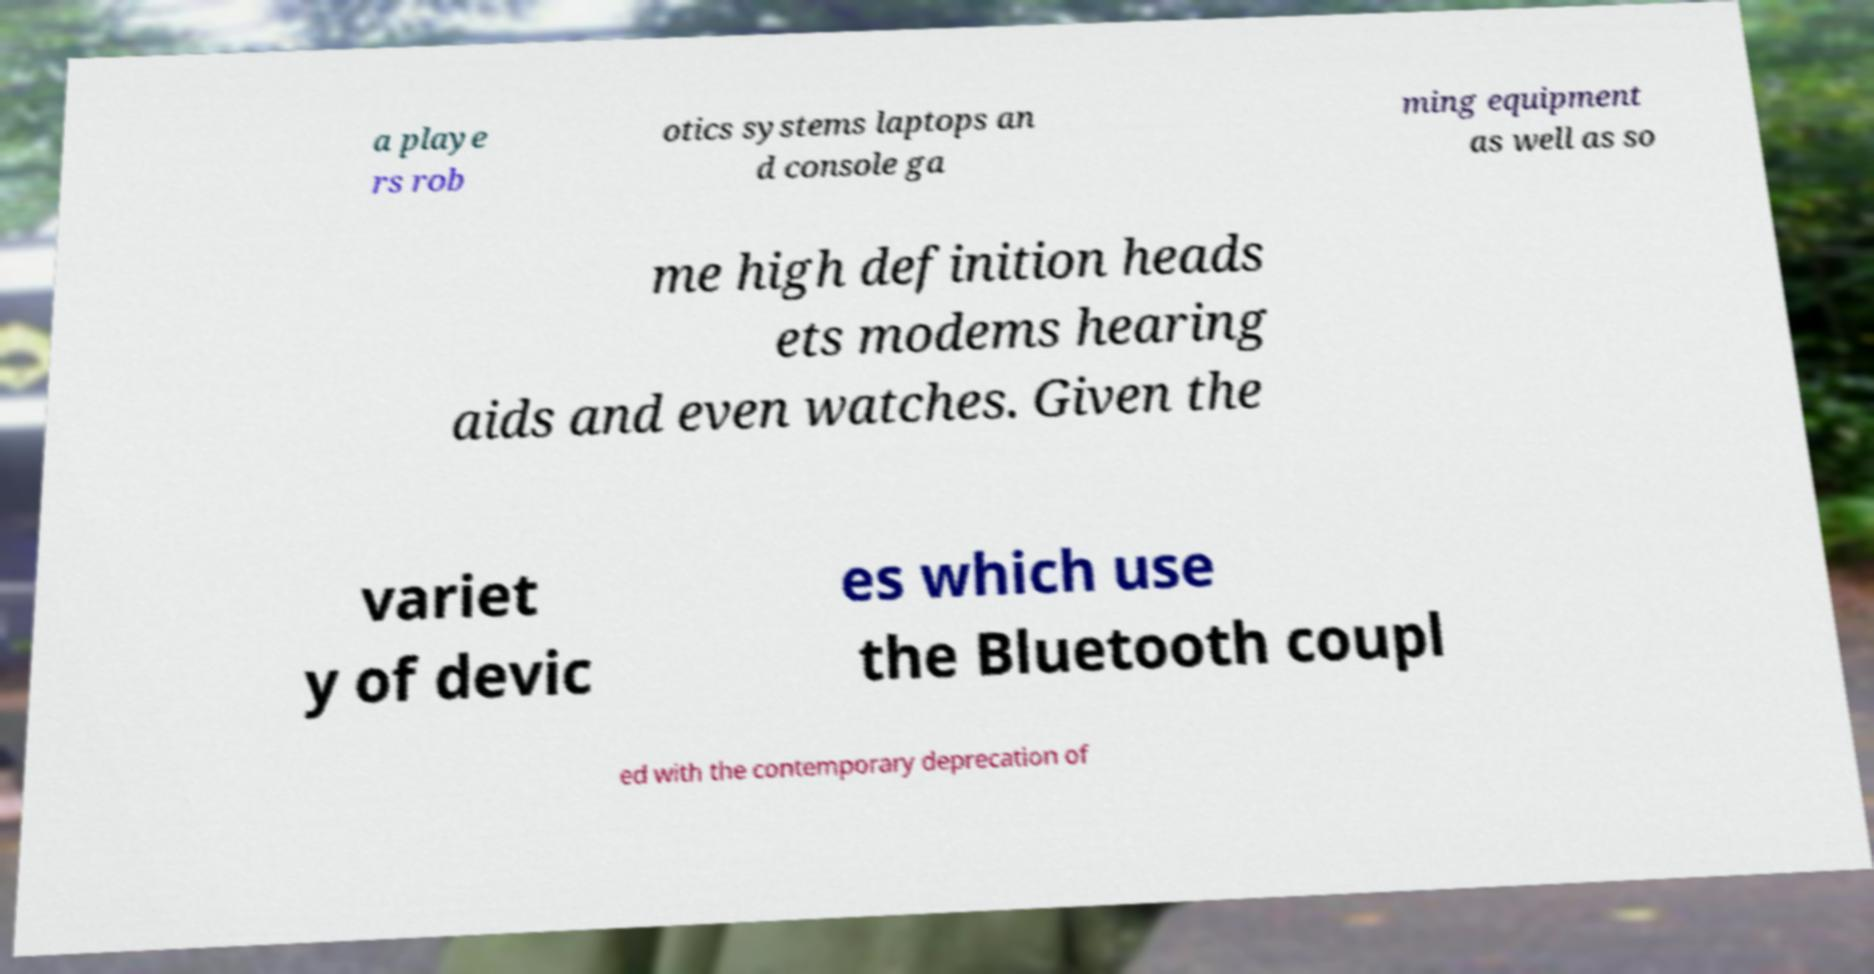Please read and relay the text visible in this image. What does it say? a playe rs rob otics systems laptops an d console ga ming equipment as well as so me high definition heads ets modems hearing aids and even watches. Given the variet y of devic es which use the Bluetooth coupl ed with the contemporary deprecation of 